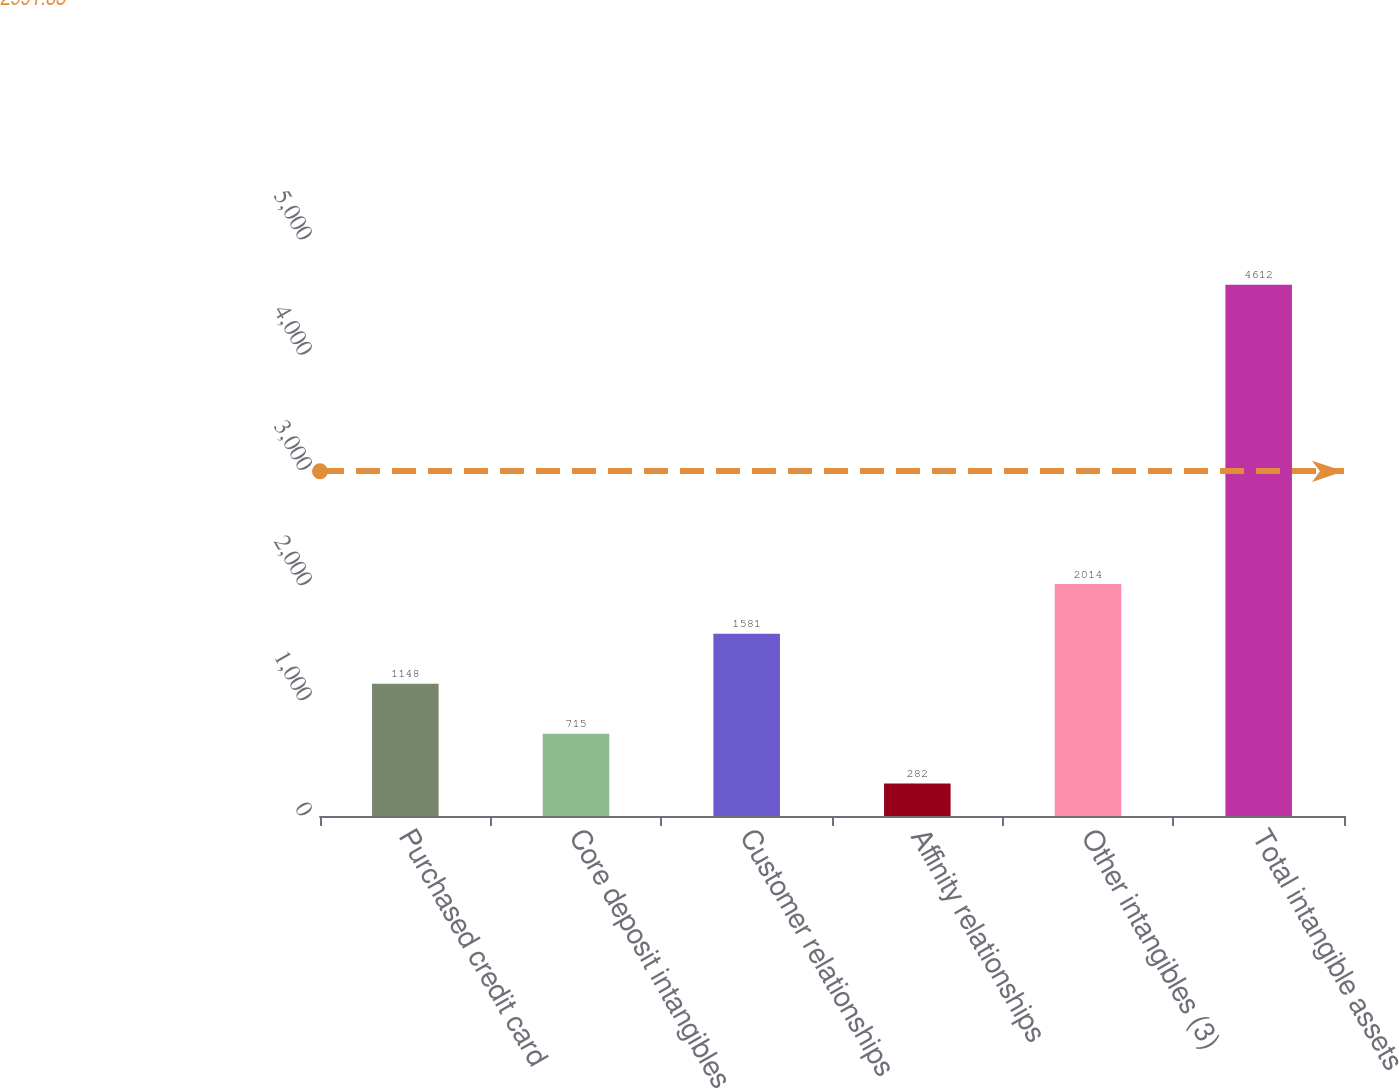Convert chart. <chart><loc_0><loc_0><loc_500><loc_500><bar_chart><fcel>Purchased credit card<fcel>Core deposit intangibles<fcel>Customer relationships<fcel>Affinity relationships<fcel>Other intangibles (3)<fcel>Total intangible assets<nl><fcel>1148<fcel>715<fcel>1581<fcel>282<fcel>2014<fcel>4612<nl></chart> 